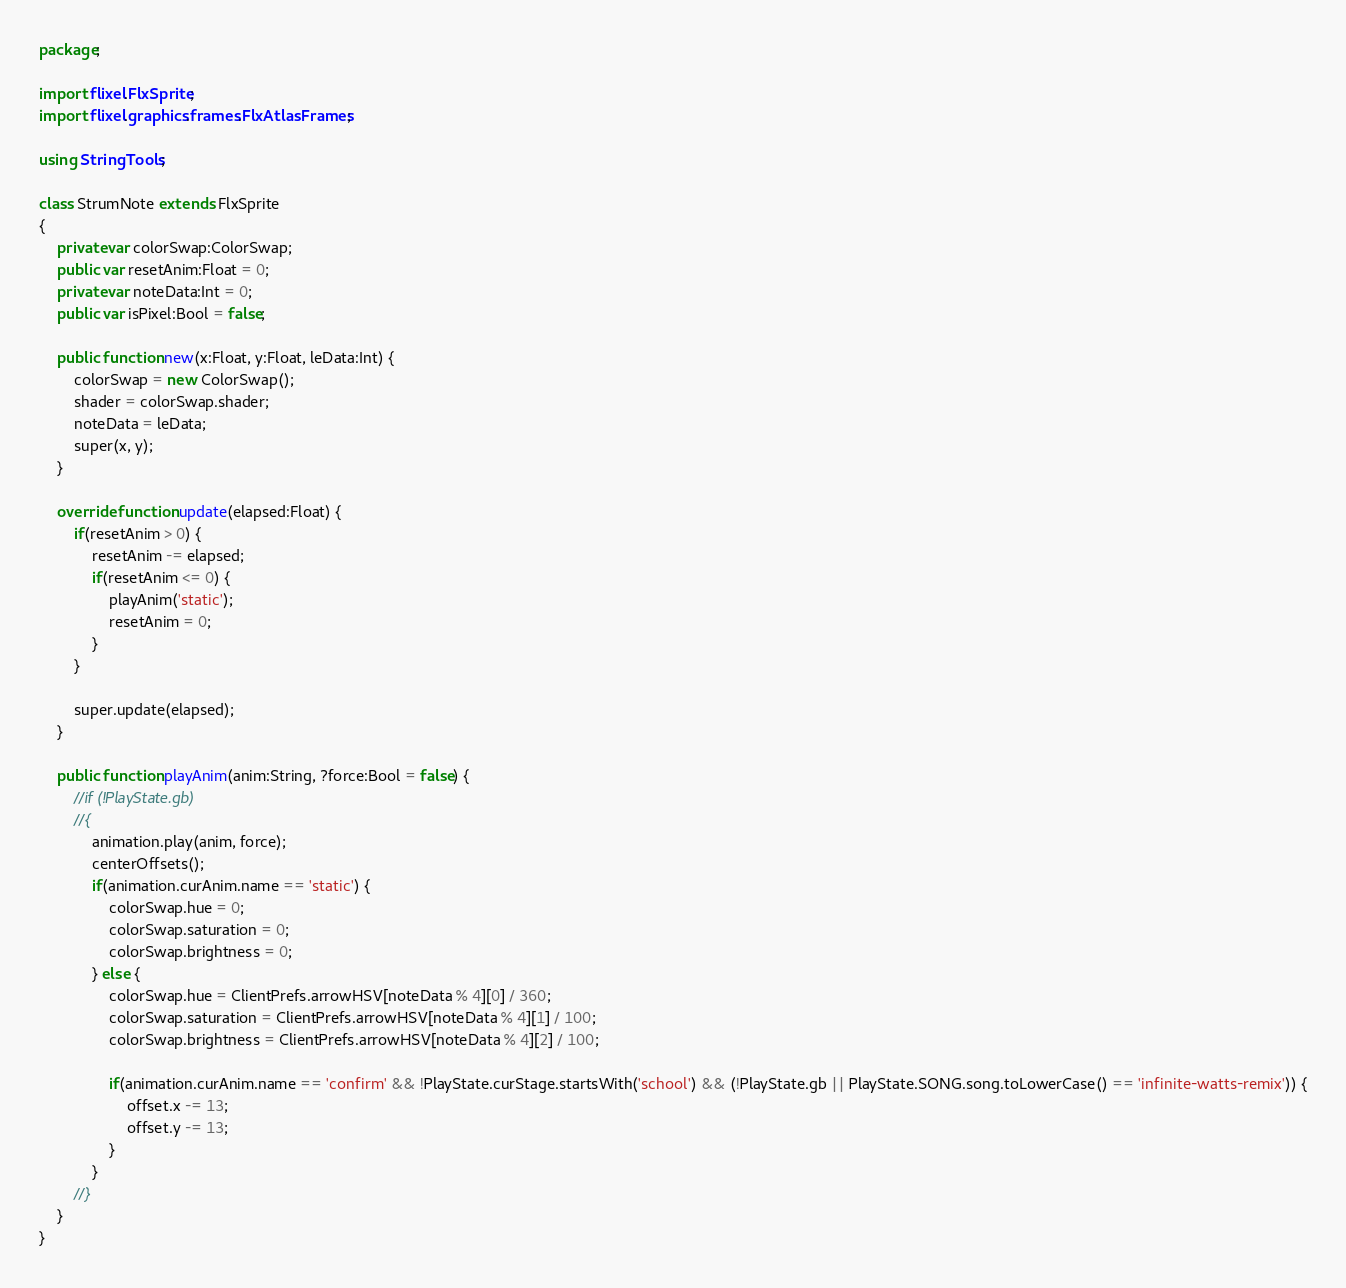<code> <loc_0><loc_0><loc_500><loc_500><_Haxe_>package;

import flixel.FlxSprite;
import flixel.graphics.frames.FlxAtlasFrames;

using StringTools;

class StrumNote extends FlxSprite
{
	private var colorSwap:ColorSwap;
	public var resetAnim:Float = 0;
	private var noteData:Int = 0;
	public var isPixel:Bool = false;

	public function new(x:Float, y:Float, leData:Int) {
		colorSwap = new ColorSwap();
		shader = colorSwap.shader;
		noteData = leData;
		super(x, y);
	}

	override function update(elapsed:Float) {
		if(resetAnim > 0) {
			resetAnim -= elapsed;
			if(resetAnim <= 0) {
				playAnim('static');
				resetAnim = 0;
			}
		}

		super.update(elapsed);
	}

	public function playAnim(anim:String, ?force:Bool = false) {
		//if (!PlayState.gb)
		//{	
			animation.play(anim, force);
			centerOffsets();
			if(animation.curAnim.name == 'static') {
				colorSwap.hue = 0;
				colorSwap.saturation = 0;
				colorSwap.brightness = 0;
			} else {
				colorSwap.hue = ClientPrefs.arrowHSV[noteData % 4][0] / 360;
				colorSwap.saturation = ClientPrefs.arrowHSV[noteData % 4][1] / 100;
				colorSwap.brightness = ClientPrefs.arrowHSV[noteData % 4][2] / 100;

				if(animation.curAnim.name == 'confirm' && !PlayState.curStage.startsWith('school') && (!PlayState.gb || PlayState.SONG.song.toLowerCase() == 'infinite-watts-remix')) {
					offset.x -= 13;
					offset.y -= 13;
				}
			}
		//}
	}
}
</code> 